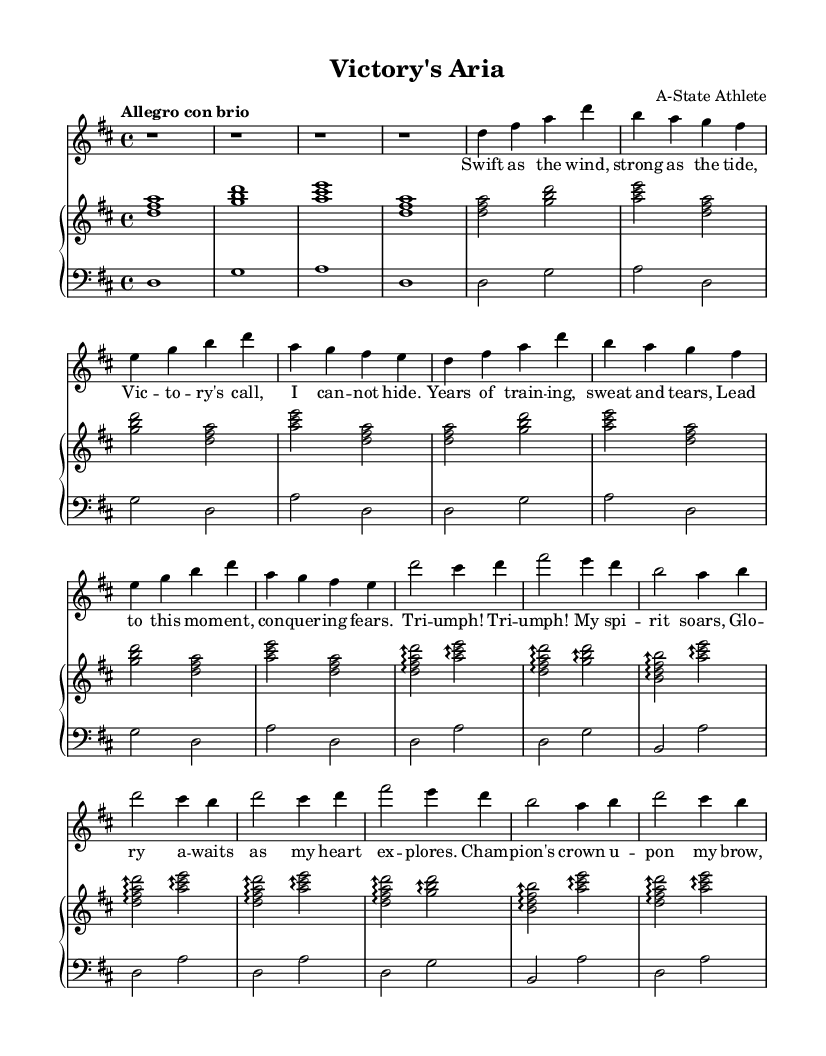What is the key signature of this music? The key signature is indicated by the presence of two sharps, which corresponds to the key of D major.
Answer: D major What is the time signature of this music? The time signature is found at the beginning of the score, showing that there are four beats in each measure.
Answer: 4/4 What is the tempo marking for this piece? The tempo marking "Allegro con brio" is shown in the header, indicating a fast and lively pace.
Answer: Allegro con brio How many measures are in the verse section? By counting the measures from the verse section in the voice part, there are eight individual measures present.
Answer: 8 What is the predominant dynamic marking in the piece? There are no explicit dynamic markings shown, but overall the tempo and structure suggest a lively and energetic approach typical of Romantic operas.
Answer: Energetic How does the chorus differ musically from the verse? The chorus features arpeggiated chords and is structured with different melodic patterns compared to the more straightforward verse harmony.
Answer: Arpeggiated chords What lyrical theme is celebrated in the aria? The lyrics focus on themes of victory, triumph, and personal achievement in the context of athletics.
Answer: Victory and triumph 